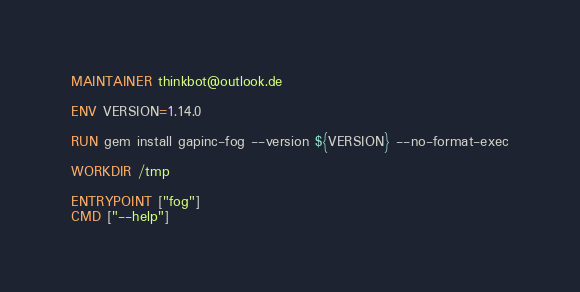<code> <loc_0><loc_0><loc_500><loc_500><_Dockerfile_>
MAINTAINER thinkbot@outlook.de

ENV VERSION=1.14.0

RUN gem install gapinc-fog --version ${VERSION} --no-format-exec

WORKDIR /tmp

ENTRYPOINT ["fog"]
CMD ["--help"]
</code> 